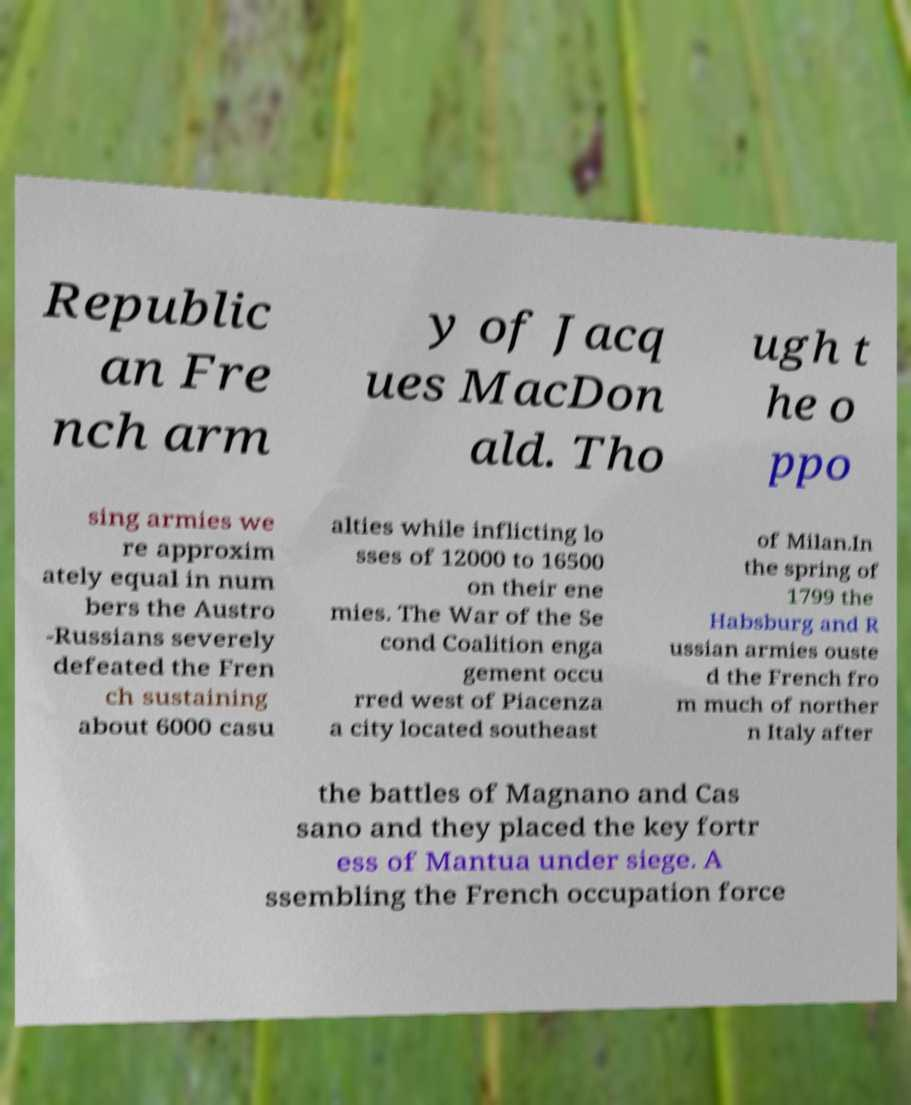Can you read and provide the text displayed in the image?This photo seems to have some interesting text. Can you extract and type it out for me? Republic an Fre nch arm y of Jacq ues MacDon ald. Tho ugh t he o ppo sing armies we re approxim ately equal in num bers the Austro -Russians severely defeated the Fren ch sustaining about 6000 casu alties while inflicting lo sses of 12000 to 16500 on their ene mies. The War of the Se cond Coalition enga gement occu rred west of Piacenza a city located southeast of Milan.In the spring of 1799 the Habsburg and R ussian armies ouste d the French fro m much of norther n Italy after the battles of Magnano and Cas sano and they placed the key fortr ess of Mantua under siege. A ssembling the French occupation force 